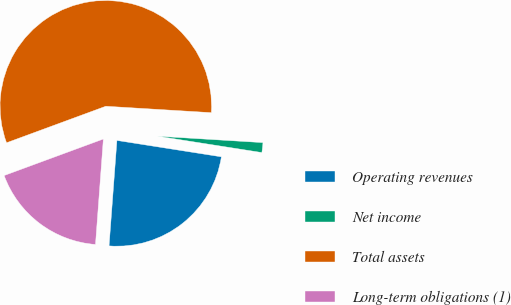Convert chart to OTSL. <chart><loc_0><loc_0><loc_500><loc_500><pie_chart><fcel>Operating revenues<fcel>Net income<fcel>Total assets<fcel>Long-term obligations (1)<nl><fcel>23.71%<fcel>1.51%<fcel>56.58%<fcel>18.2%<nl></chart> 